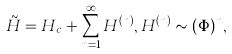<formula> <loc_0><loc_0><loc_500><loc_500>\tilde { H } = H _ { c } + \sum _ { n = 1 } ^ { \infty } H ^ { ( n ) } , H ^ { ( n ) } \sim ( \Phi ) ^ { n } ,</formula> 